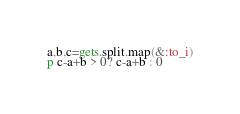<code> <loc_0><loc_0><loc_500><loc_500><_Ruby_>a,b,c=gets.split.map(&:to_i)
p c-a+b > 0? c-a+b : 0</code> 